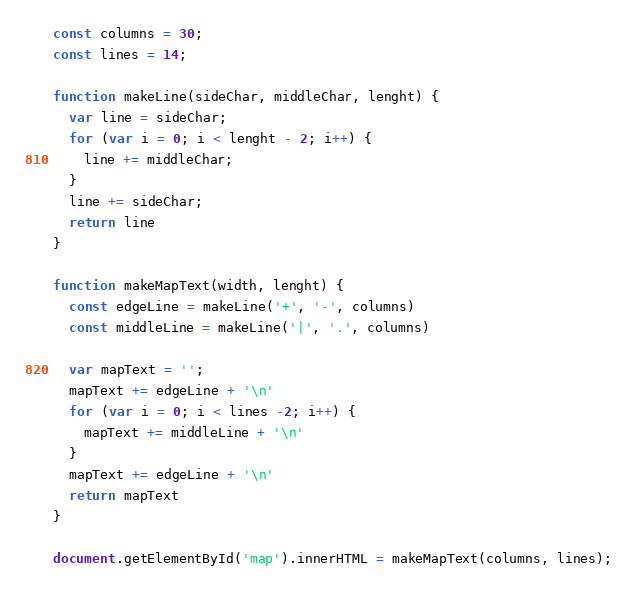<code> <loc_0><loc_0><loc_500><loc_500><_JavaScript_>const columns = 30;
const lines = 14;

function makeLine(sideChar, middleChar, lenght) {
  var line = sideChar;
  for (var i = 0; i < lenght - 2; i++) {
    line += middleChar;
  }
  line += sideChar;
  return line
}

function makeMapText(width, lenght) {
  const edgeLine = makeLine('+', '-', columns)
  const middleLine = makeLine('|', '.', columns)

  var mapText = '';
  mapText += edgeLine + '\n'
  for (var i = 0; i < lines -2; i++) {
    mapText += middleLine + '\n'
  }
  mapText += edgeLine + '\n'
  return mapText
}

document.getElementById('map').innerHTML = makeMapText(columns, lines);
</code> 